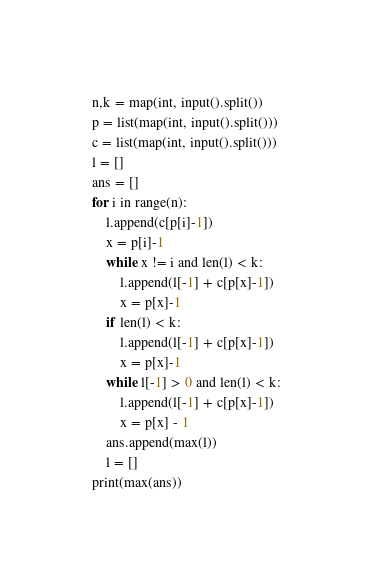<code> <loc_0><loc_0><loc_500><loc_500><_Python_>n,k = map(int, input().split())
p = list(map(int, input().split()))
c = list(map(int, input().split()))
l = []
ans = []
for i in range(n):
    l.append(c[p[i]-1])
    x = p[i]-1
    while x != i and len(l) < k:
        l.append(l[-1] + c[p[x]-1])
        x = p[x]-1
    if len(l) < k:
        l.append(l[-1] + c[p[x]-1])
        x = p[x]-1
    while l[-1] > 0 and len(l) < k:
        l.append(l[-1] + c[p[x]-1])
        x = p[x] - 1
    ans.append(max(l))
    l = []
print(max(ans))</code> 